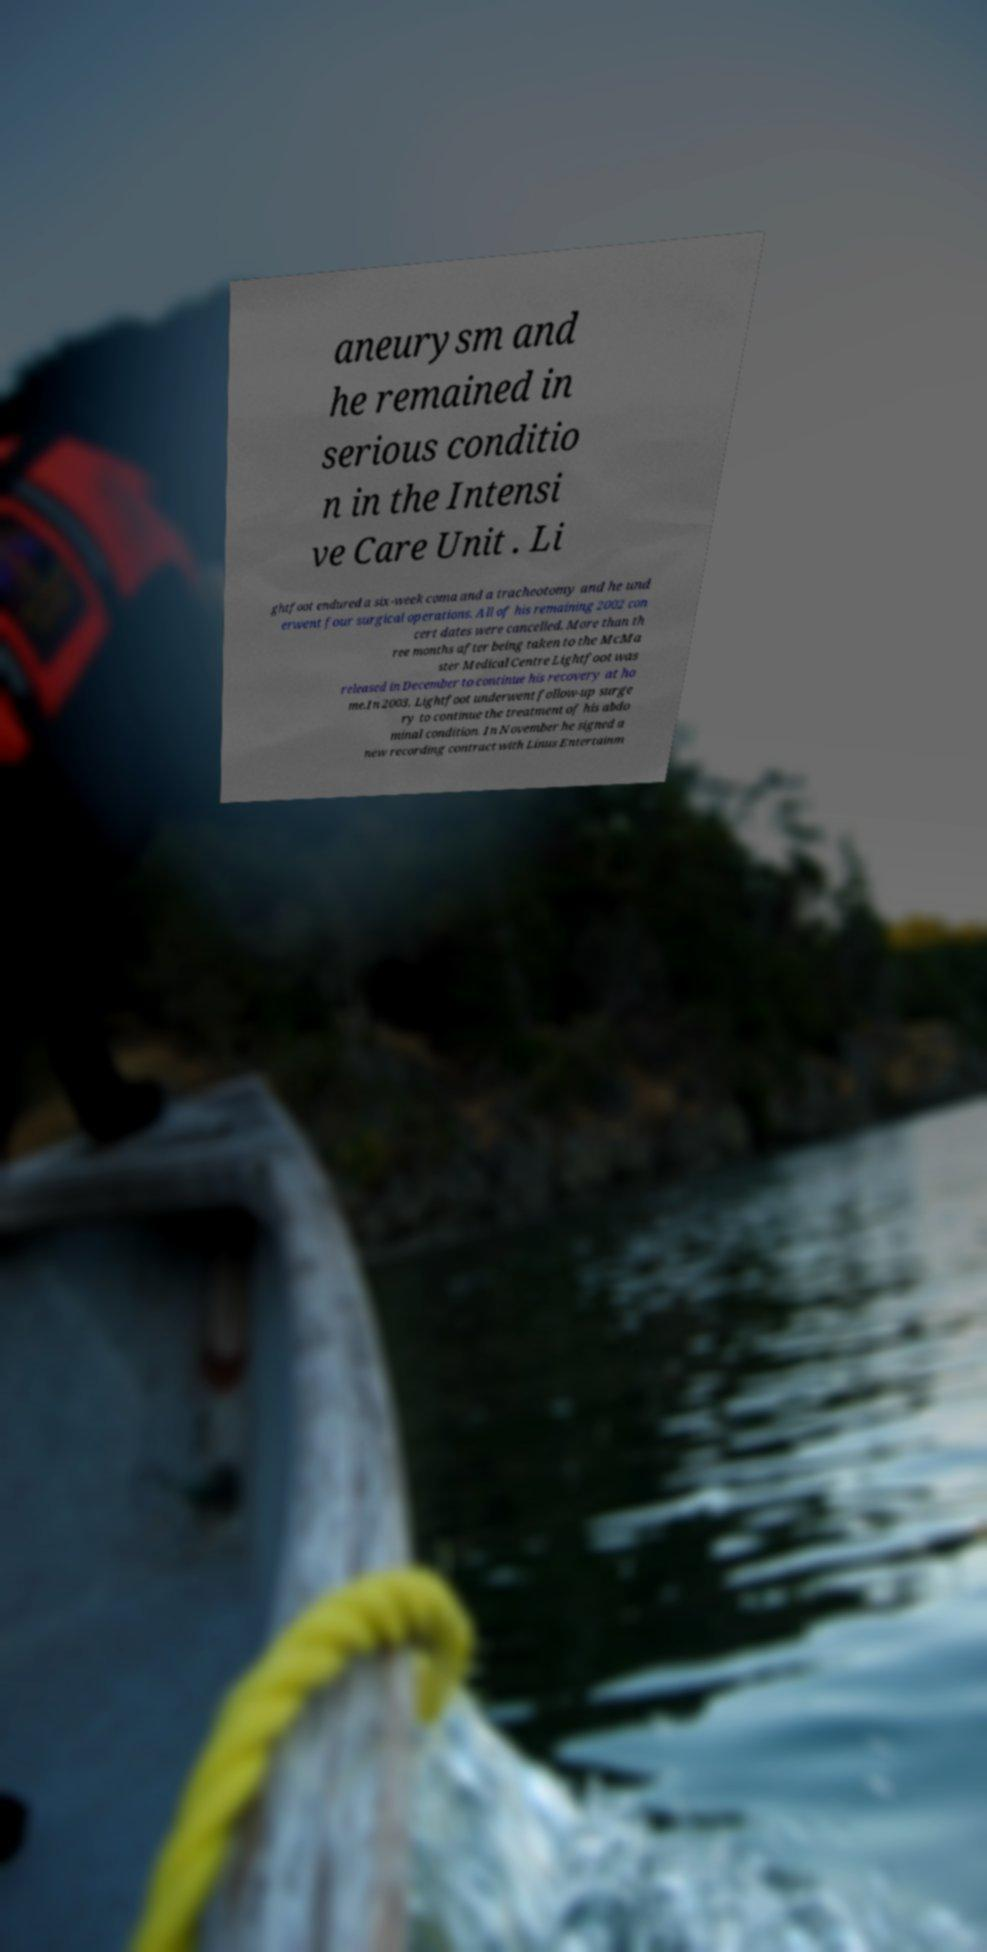Can you accurately transcribe the text from the provided image for me? aneurysm and he remained in serious conditio n in the Intensi ve Care Unit . Li ghtfoot endured a six-week coma and a tracheotomy and he und erwent four surgical operations. All of his remaining 2002 con cert dates were cancelled. More than th ree months after being taken to the McMa ster Medical Centre Lightfoot was released in December to continue his recovery at ho me.In 2003, Lightfoot underwent follow-up surge ry to continue the treatment of his abdo minal condition. In November he signed a new recording contract with Linus Entertainm 